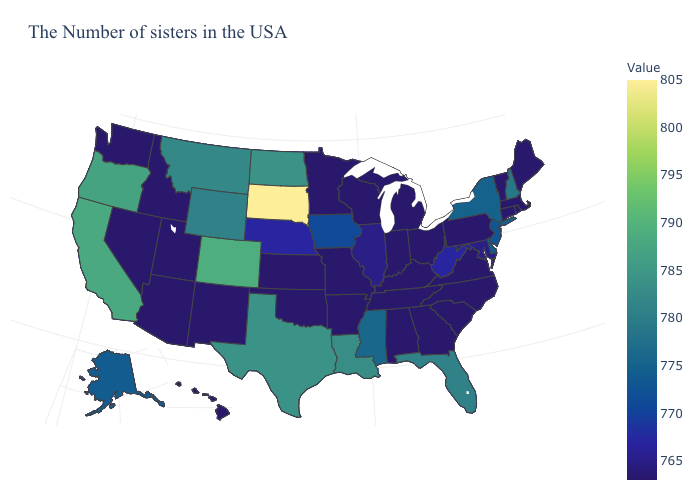Among the states that border Washington , does Idaho have the highest value?
Answer briefly. No. Does Wisconsin have the highest value in the MidWest?
Be succinct. No. Does South Dakota have the highest value in the USA?
Give a very brief answer. Yes. Which states have the highest value in the USA?
Give a very brief answer. South Dakota. Among the states that border New York , does New Jersey have the lowest value?
Short answer required. No. Which states have the lowest value in the Northeast?
Answer briefly. Maine, Massachusetts, Rhode Island, Vermont, Connecticut, Pennsylvania. Does Iowa have the lowest value in the USA?
Write a very short answer. No. Which states have the highest value in the USA?
Give a very brief answer. South Dakota. 